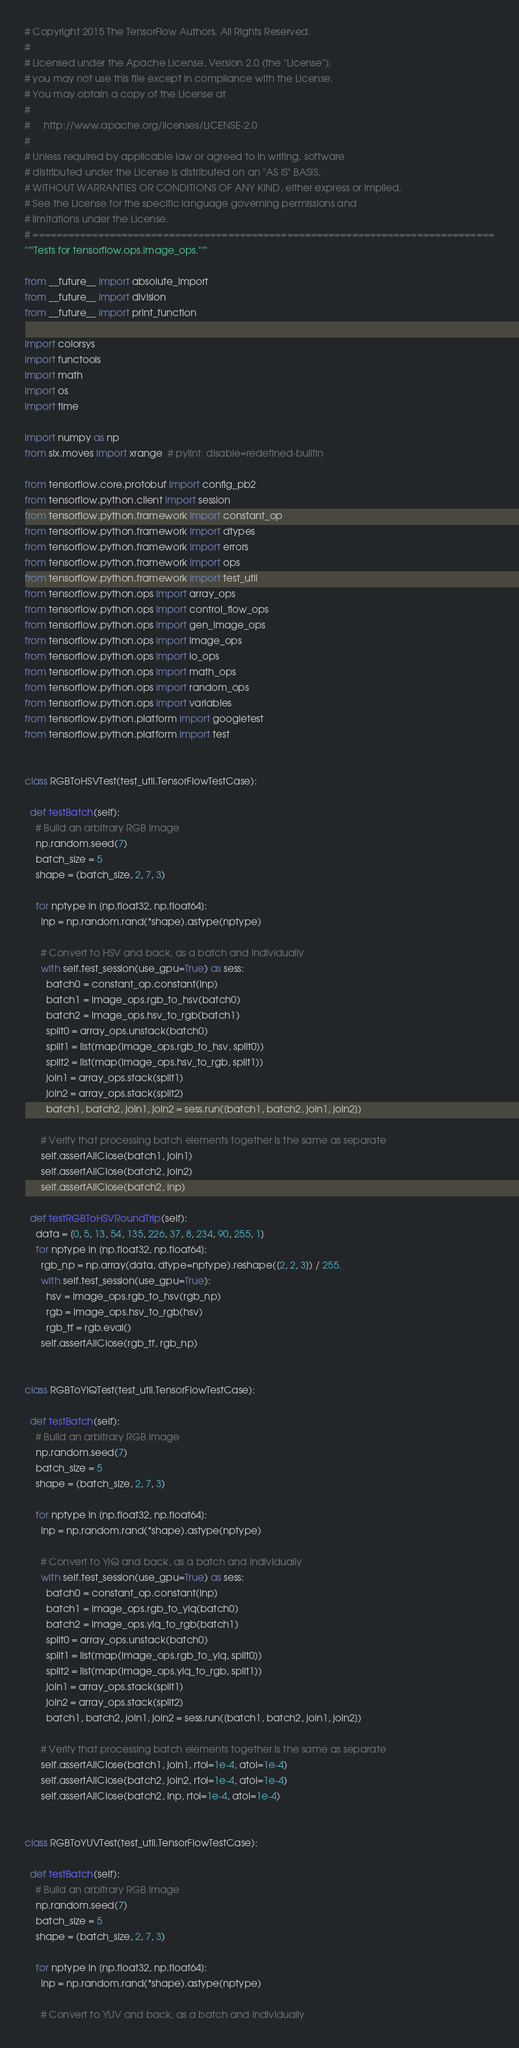Convert code to text. <code><loc_0><loc_0><loc_500><loc_500><_Python_># Copyright 2015 The TensorFlow Authors. All Rights Reserved.
#
# Licensed under the Apache License, Version 2.0 (the "License");
# you may not use this file except in compliance with the License.
# You may obtain a copy of the License at
#
#     http://www.apache.org/licenses/LICENSE-2.0
#
# Unless required by applicable law or agreed to in writing, software
# distributed under the License is distributed on an "AS IS" BASIS,
# WITHOUT WARRANTIES OR CONDITIONS OF ANY KIND, either express or implied.
# See the License for the specific language governing permissions and
# limitations under the License.
# ==============================================================================
"""Tests for tensorflow.ops.image_ops."""

from __future__ import absolute_import
from __future__ import division
from __future__ import print_function

import colorsys
import functools
import math
import os
import time

import numpy as np
from six.moves import xrange  # pylint: disable=redefined-builtin

from tensorflow.core.protobuf import config_pb2
from tensorflow.python.client import session
from tensorflow.python.framework import constant_op
from tensorflow.python.framework import dtypes
from tensorflow.python.framework import errors
from tensorflow.python.framework import ops
from tensorflow.python.framework import test_util
from tensorflow.python.ops import array_ops
from tensorflow.python.ops import control_flow_ops
from tensorflow.python.ops import gen_image_ops
from tensorflow.python.ops import image_ops
from tensorflow.python.ops import io_ops
from tensorflow.python.ops import math_ops
from tensorflow.python.ops import random_ops
from tensorflow.python.ops import variables
from tensorflow.python.platform import googletest
from tensorflow.python.platform import test


class RGBToHSVTest(test_util.TensorFlowTestCase):

  def testBatch(self):
    # Build an arbitrary RGB image
    np.random.seed(7)
    batch_size = 5
    shape = (batch_size, 2, 7, 3)

    for nptype in [np.float32, np.float64]:
      inp = np.random.rand(*shape).astype(nptype)

      # Convert to HSV and back, as a batch and individually
      with self.test_session(use_gpu=True) as sess:
        batch0 = constant_op.constant(inp)
        batch1 = image_ops.rgb_to_hsv(batch0)
        batch2 = image_ops.hsv_to_rgb(batch1)
        split0 = array_ops.unstack(batch0)
        split1 = list(map(image_ops.rgb_to_hsv, split0))
        split2 = list(map(image_ops.hsv_to_rgb, split1))
        join1 = array_ops.stack(split1)
        join2 = array_ops.stack(split2)
        batch1, batch2, join1, join2 = sess.run([batch1, batch2, join1, join2])

      # Verify that processing batch elements together is the same as separate
      self.assertAllClose(batch1, join1)
      self.assertAllClose(batch2, join2)
      self.assertAllClose(batch2, inp)

  def testRGBToHSVRoundTrip(self):
    data = [0, 5, 13, 54, 135, 226, 37, 8, 234, 90, 255, 1]
    for nptype in [np.float32, np.float64]:
      rgb_np = np.array(data, dtype=nptype).reshape([2, 2, 3]) / 255.
      with self.test_session(use_gpu=True):
        hsv = image_ops.rgb_to_hsv(rgb_np)
        rgb = image_ops.hsv_to_rgb(hsv)
        rgb_tf = rgb.eval()
      self.assertAllClose(rgb_tf, rgb_np)


class RGBToYIQTest(test_util.TensorFlowTestCase):

  def testBatch(self):
    # Build an arbitrary RGB image
    np.random.seed(7)
    batch_size = 5
    shape = (batch_size, 2, 7, 3)

    for nptype in [np.float32, np.float64]:
      inp = np.random.rand(*shape).astype(nptype)

      # Convert to YIQ and back, as a batch and individually
      with self.test_session(use_gpu=True) as sess:
        batch0 = constant_op.constant(inp)
        batch1 = image_ops.rgb_to_yiq(batch0)
        batch2 = image_ops.yiq_to_rgb(batch1)
        split0 = array_ops.unstack(batch0)
        split1 = list(map(image_ops.rgb_to_yiq, split0))
        split2 = list(map(image_ops.yiq_to_rgb, split1))
        join1 = array_ops.stack(split1)
        join2 = array_ops.stack(split2)
        batch1, batch2, join1, join2 = sess.run([batch1, batch2, join1, join2])

      # Verify that processing batch elements together is the same as separate
      self.assertAllClose(batch1, join1, rtol=1e-4, atol=1e-4)
      self.assertAllClose(batch2, join2, rtol=1e-4, atol=1e-4)
      self.assertAllClose(batch2, inp, rtol=1e-4, atol=1e-4)


class RGBToYUVTest(test_util.TensorFlowTestCase):

  def testBatch(self):
    # Build an arbitrary RGB image
    np.random.seed(7)
    batch_size = 5
    shape = (batch_size, 2, 7, 3)

    for nptype in [np.float32, np.float64]:
      inp = np.random.rand(*shape).astype(nptype)

      # Convert to YUV and back, as a batch and individually</code> 